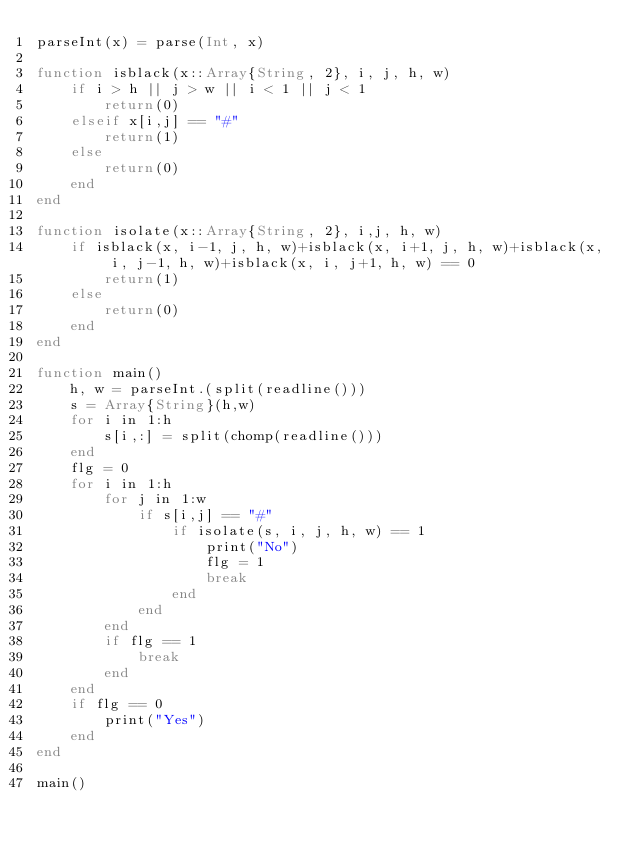<code> <loc_0><loc_0><loc_500><loc_500><_Julia_>parseInt(x) = parse(Int, x)

function isblack(x::Array{String, 2}, i, j, h, w)
	if i > h || j > w || i < 1 || j < 1
		return(0)
	elseif x[i,j] == "#"
		return(1)
	else
		return(0)
	end
end

function isolate(x::Array{String, 2}, i,j, h, w)
	if isblack(x, i-1, j, h, w)+isblack(x, i+1, j, h, w)+isblack(x, i, j-1, h, w)+isblack(x, i, j+1, h, w) == 0
		return(1)
	else
		return(0)
	end
end

function main()
	h, w = parseInt.(split(readline()))
	s = Array{String}(h,w)
	for i in 1:h
		s[i,:] = split(chomp(readline()))
	end
	flg = 0
	for i in 1:h
		for j in 1:w
			if s[i,j] == "#"
				if isolate(s, i, j, h, w) == 1
					print("No")
					flg = 1
					break
				end
			end
		end
		if flg == 1
			break
		end
	end
	if flg == 0
		print("Yes")
	end
end

main()</code> 